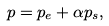<formula> <loc_0><loc_0><loc_500><loc_500>p = p _ { e } + \alpha p _ { s } ,</formula> 